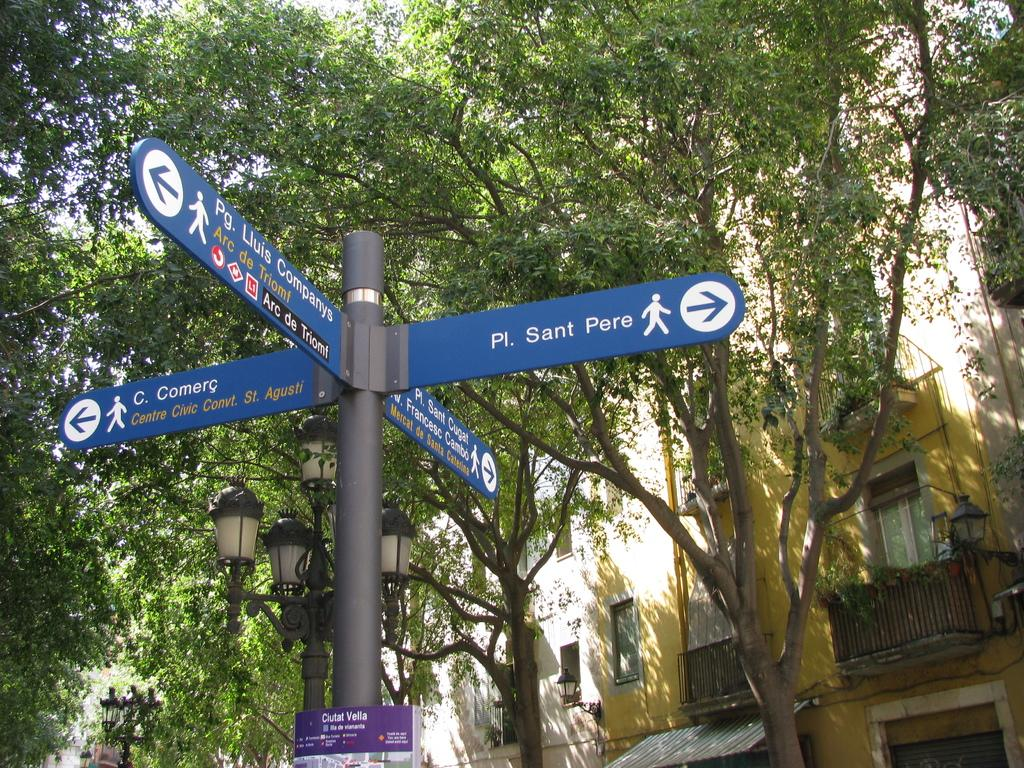What is attached to the pole in the image? There are blue colored boards attached to a pole in the image. What can be seen in the background of the image? There are light poles, trees with green color, and a building with a yellow color in the background of the image. What type of disease is affecting the trees in the image? There is no indication of any disease affecting the trees in the image; they appear to be healthy green trees. 